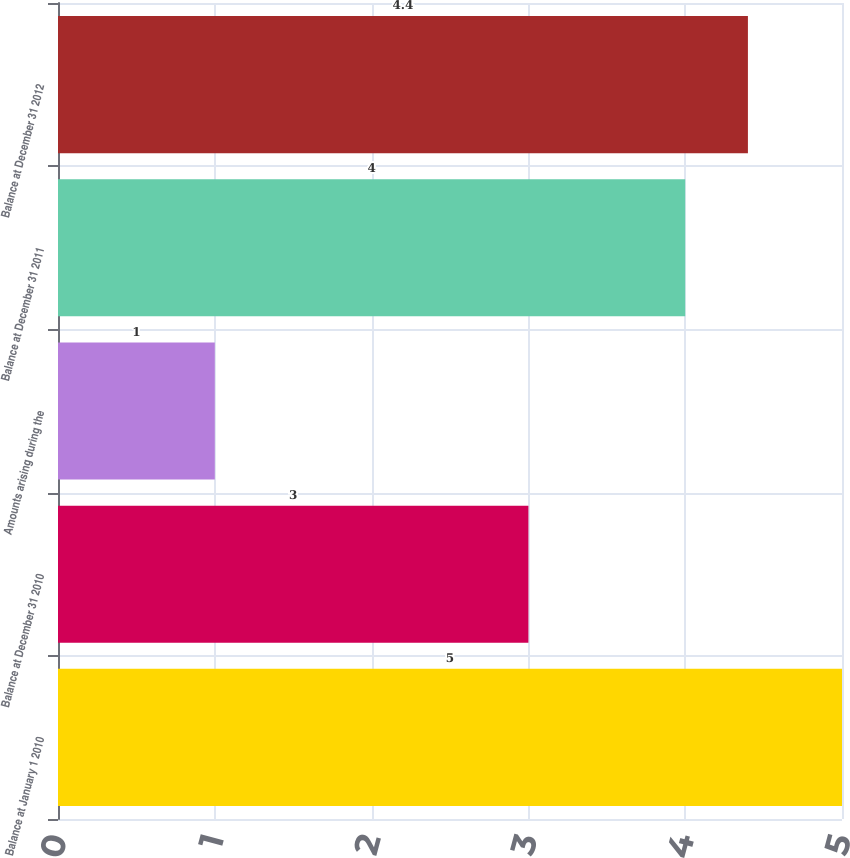Convert chart to OTSL. <chart><loc_0><loc_0><loc_500><loc_500><bar_chart><fcel>Balance at January 1 2010<fcel>Balance at December 31 2010<fcel>Amounts arising during the<fcel>Balance at December 31 2011<fcel>Balance at December 31 2012<nl><fcel>5<fcel>3<fcel>1<fcel>4<fcel>4.4<nl></chart> 